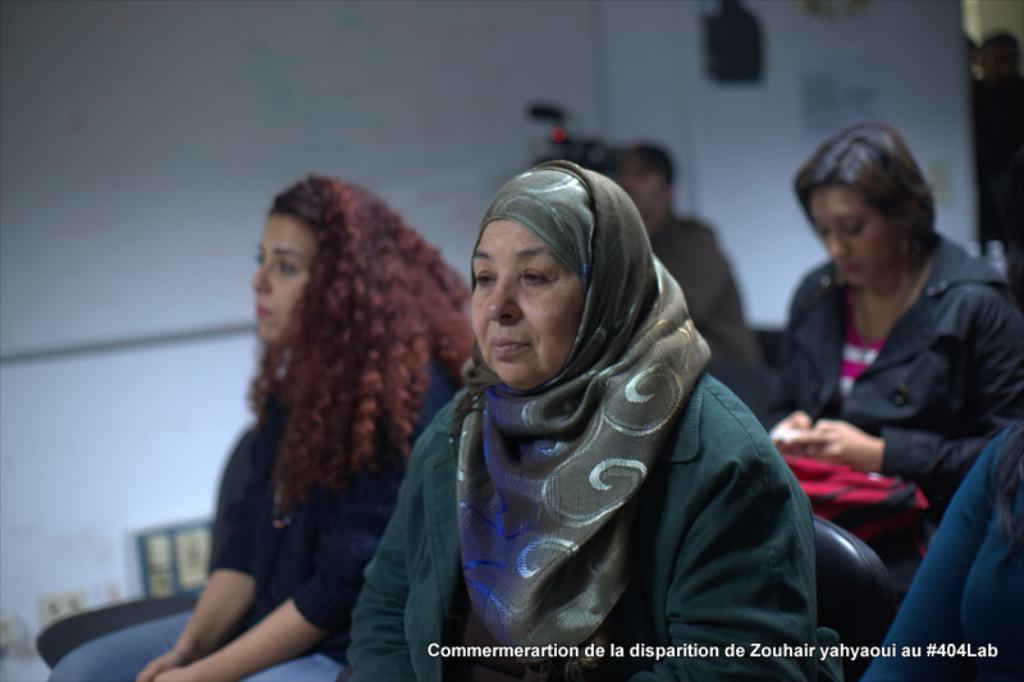How would you summarize this image in a sentence or two? In the picture we can see some people are sitting on the chairs, in the background, we can see a man sitting with a camera and behind him we can see a wall with a white color board and some things beside it. 